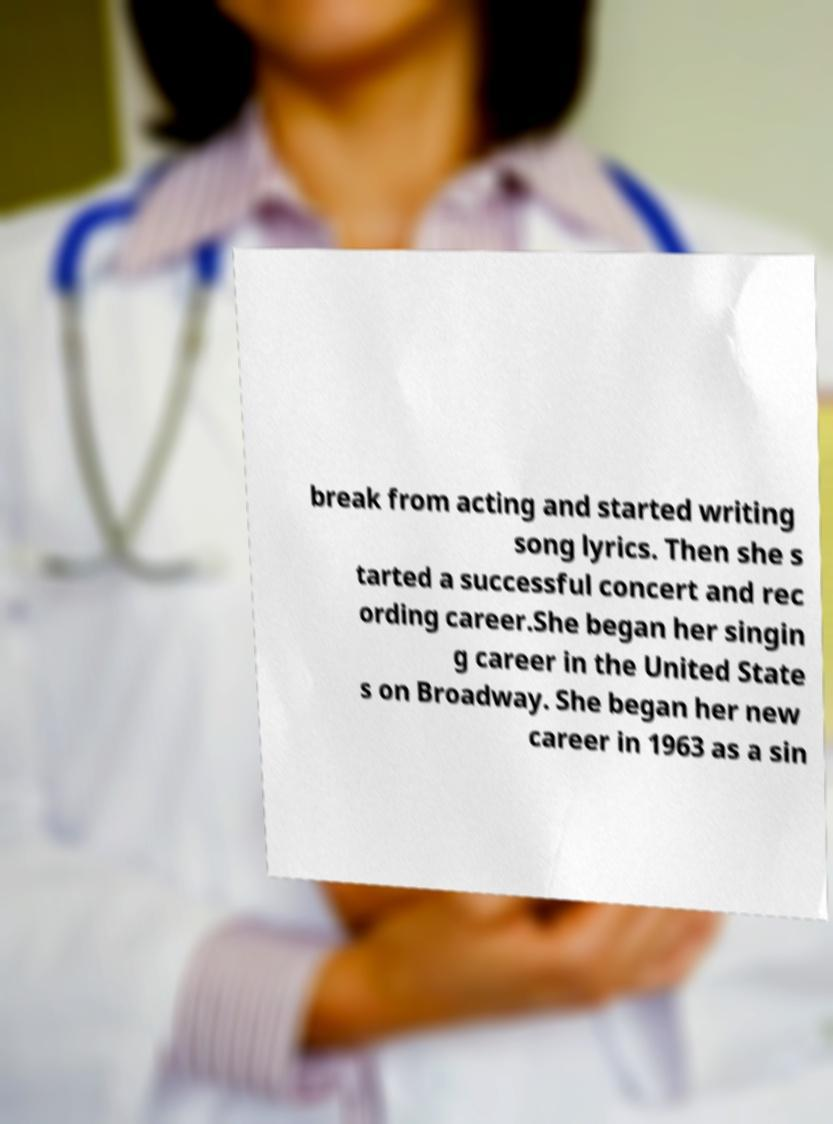Could you extract and type out the text from this image? break from acting and started writing song lyrics. Then she s tarted a successful concert and rec ording career.She began her singin g career in the United State s on Broadway. She began her new career in 1963 as a sin 